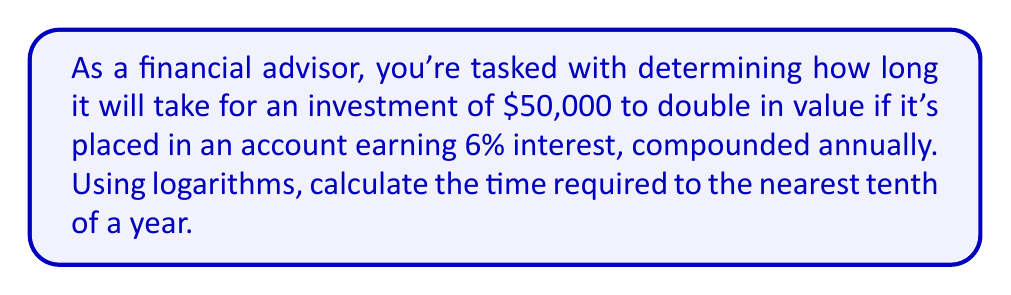Could you help me with this problem? Let's approach this step-by-step using the compound interest formula and logarithms:

1) The compound interest formula is:
   $A = P(1 + r)^t$
   Where:
   $A$ = final amount
   $P$ = principal (initial investment)
   $r$ = annual interest rate (as a decimal)
   $t$ = time in years

2) We want to find when the amount doubles, so:
   $2P = P(1 + r)^t$

3) Divide both sides by $P$:
   $2 = (1 + r)^t$

4) Take the natural log of both sides:
   $\ln(2) = \ln((1 + r)^t)$

5) Use the logarithm property $\ln(a^b) = b\ln(a)$:
   $\ln(2) = t\ln(1 + r)$

6) Solve for $t$:
   $t = \frac{\ln(2)}{\ln(1 + r)}$

7) Now, plug in the values:
   $r = 0.06$ (6% as a decimal)
   
   $t = \frac{\ln(2)}{\ln(1 + 0.06)}$

8) Calculate:
   $t = \frac{0.6931471806}{0.0582689492} \approx 11.8957$ years

9) Rounding to the nearest tenth:
   $t \approx 11.9$ years
Answer: 11.9 years 